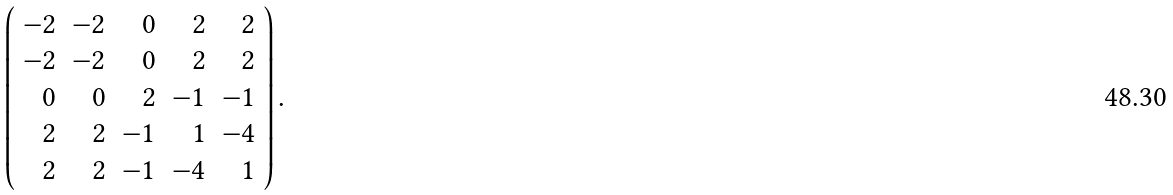<formula> <loc_0><loc_0><loc_500><loc_500>\left ( \begin{array} { r r r r r } - 2 & - 2 & 0 & 2 & 2 \\ - 2 & - 2 & 0 & 2 & 2 \\ 0 & 0 & 2 & - 1 & - 1 \\ 2 & 2 & - 1 & 1 & - 4 \\ 2 & 2 & - 1 & - 4 & 1 \\ \end{array} \right ) .</formula> 